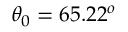<formula> <loc_0><loc_0><loc_500><loc_500>\theta _ { 0 } = 6 5 . 2 2 ^ { o }</formula> 